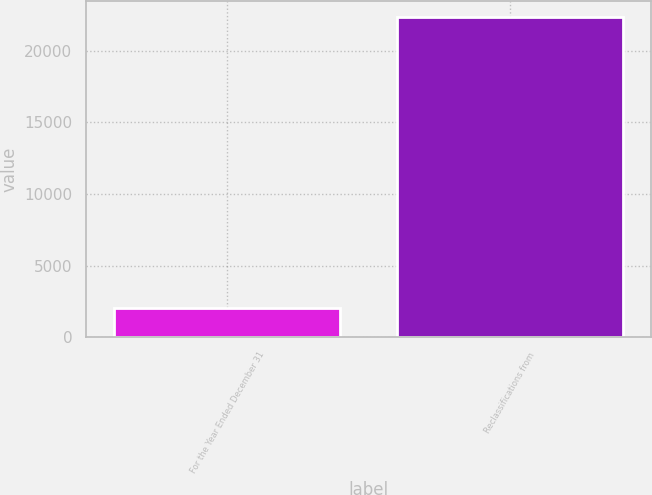Convert chart to OTSL. <chart><loc_0><loc_0><loc_500><loc_500><bar_chart><fcel>For the Year Ended December 31<fcel>Reclassifications from<nl><fcel>2016<fcel>22384<nl></chart> 